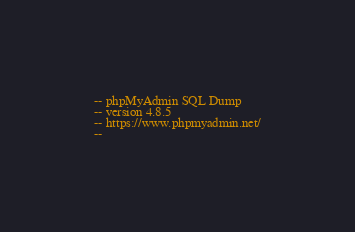Convert code to text. <code><loc_0><loc_0><loc_500><loc_500><_SQL_>-- phpMyAdmin SQL Dump
-- version 4.8.5
-- https://www.phpmyadmin.net/
--</code> 